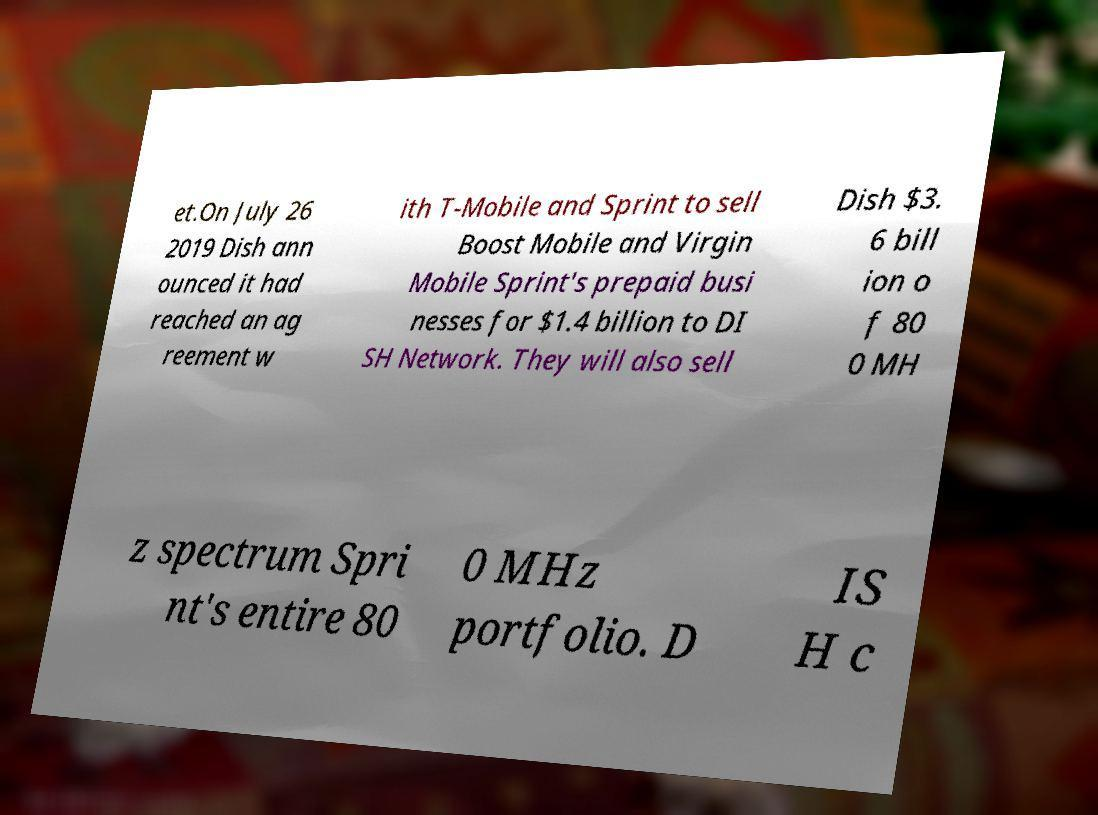There's text embedded in this image that I need extracted. Can you transcribe it verbatim? et.On July 26 2019 Dish ann ounced it had reached an ag reement w ith T-Mobile and Sprint to sell Boost Mobile and Virgin Mobile Sprint's prepaid busi nesses for $1.4 billion to DI SH Network. They will also sell Dish $3. 6 bill ion o f 80 0 MH z spectrum Spri nt's entire 80 0 MHz portfolio. D IS H c 